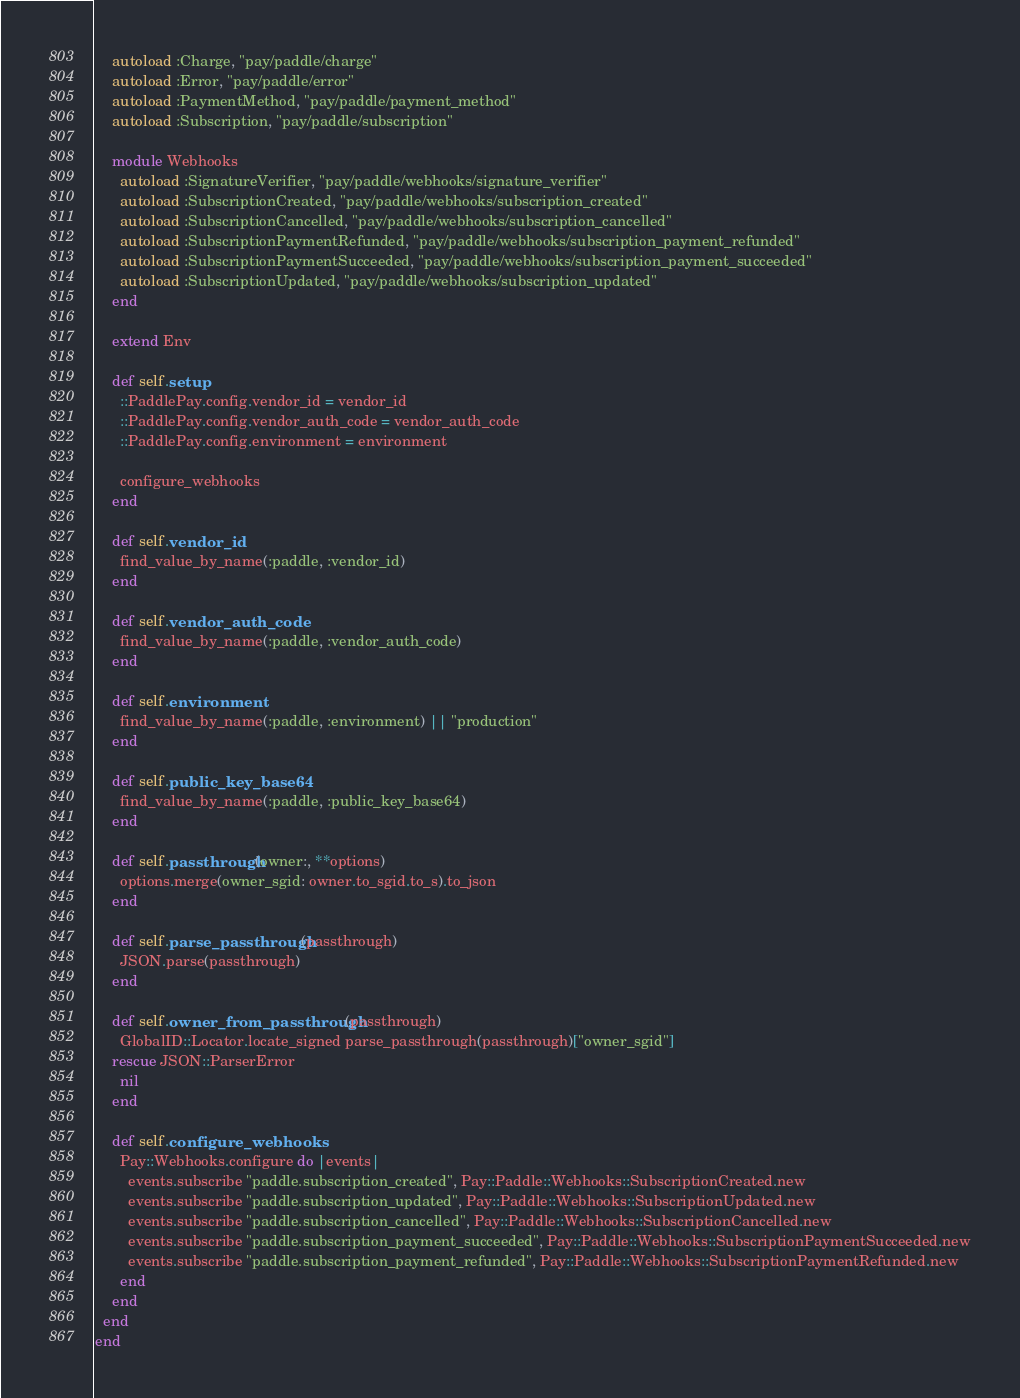<code> <loc_0><loc_0><loc_500><loc_500><_Ruby_>    autoload :Charge, "pay/paddle/charge"
    autoload :Error, "pay/paddle/error"
    autoload :PaymentMethod, "pay/paddle/payment_method"
    autoload :Subscription, "pay/paddle/subscription"

    module Webhooks
      autoload :SignatureVerifier, "pay/paddle/webhooks/signature_verifier"
      autoload :SubscriptionCreated, "pay/paddle/webhooks/subscription_created"
      autoload :SubscriptionCancelled, "pay/paddle/webhooks/subscription_cancelled"
      autoload :SubscriptionPaymentRefunded, "pay/paddle/webhooks/subscription_payment_refunded"
      autoload :SubscriptionPaymentSucceeded, "pay/paddle/webhooks/subscription_payment_succeeded"
      autoload :SubscriptionUpdated, "pay/paddle/webhooks/subscription_updated"
    end

    extend Env

    def self.setup
      ::PaddlePay.config.vendor_id = vendor_id
      ::PaddlePay.config.vendor_auth_code = vendor_auth_code
      ::PaddlePay.config.environment = environment

      configure_webhooks
    end

    def self.vendor_id
      find_value_by_name(:paddle, :vendor_id)
    end

    def self.vendor_auth_code
      find_value_by_name(:paddle, :vendor_auth_code)
    end

    def self.environment
      find_value_by_name(:paddle, :environment) || "production"
    end

    def self.public_key_base64
      find_value_by_name(:paddle, :public_key_base64)
    end

    def self.passthrough(owner:, **options)
      options.merge(owner_sgid: owner.to_sgid.to_s).to_json
    end

    def self.parse_passthrough(passthrough)
      JSON.parse(passthrough)
    end

    def self.owner_from_passthrough(passthrough)
      GlobalID::Locator.locate_signed parse_passthrough(passthrough)["owner_sgid"]
    rescue JSON::ParserError
      nil
    end

    def self.configure_webhooks
      Pay::Webhooks.configure do |events|
        events.subscribe "paddle.subscription_created", Pay::Paddle::Webhooks::SubscriptionCreated.new
        events.subscribe "paddle.subscription_updated", Pay::Paddle::Webhooks::SubscriptionUpdated.new
        events.subscribe "paddle.subscription_cancelled", Pay::Paddle::Webhooks::SubscriptionCancelled.new
        events.subscribe "paddle.subscription_payment_succeeded", Pay::Paddle::Webhooks::SubscriptionPaymentSucceeded.new
        events.subscribe "paddle.subscription_payment_refunded", Pay::Paddle::Webhooks::SubscriptionPaymentRefunded.new
      end
    end
  end
end
</code> 